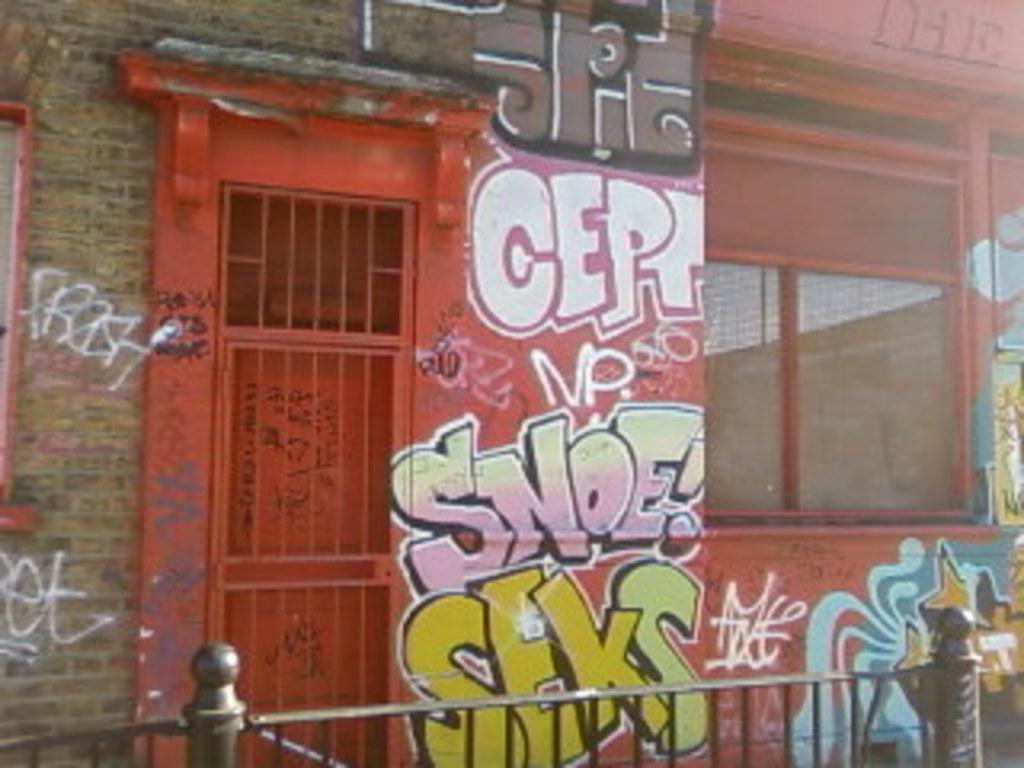Could you give a brief overview of what you see in this image? In this image in the front there is a fence. In the background there is a building and on the wall of the building there is some text written on it and there are windows and there is a door. 